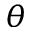Convert formula to latex. <formula><loc_0><loc_0><loc_500><loc_500>\theta</formula> 